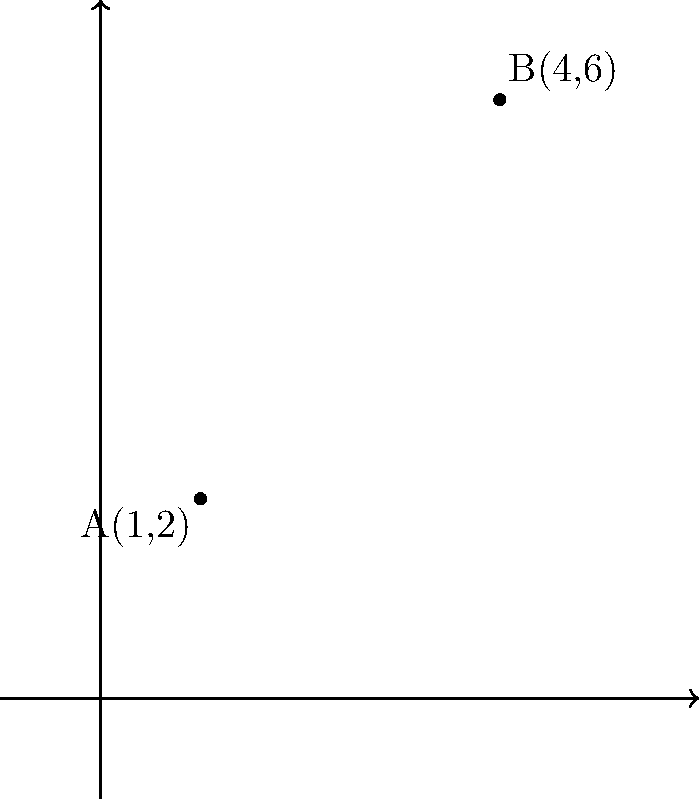In the latest film set, two crucial props are placed at coordinates A(1,2) and B(4,6) on the studio floor grid. As a film critic, you need to determine the distance between these props to assess the cinematographer's framing technique. Using the distance formula, calculate the distance between points A and B. To find the distance between two points on a coordinate plane, we use the distance formula:

$$d = \sqrt{(x_2 - x_1)^2 + (y_2 - y_1)^2}$$

Where $(x_1, y_1)$ are the coordinates of the first point and $(x_2, y_2)$ are the coordinates of the second point.

Given:
Point A: $(1, 2)$
Point B: $(4, 6)$

Let's plug these values into the formula:

$d = \sqrt{(4 - 1)^2 + (6 - 2)^2}$

Now, let's solve step by step:

1) First, calculate the differences:
   $d = \sqrt{(3)^2 + (4)^2}$

2) Square the differences:
   $d = \sqrt{9 + 16}$

3) Add the squared differences:
   $d = \sqrt{25}$

4) Calculate the square root:
   $d = 5$

Therefore, the distance between points A and B is 5 units.
Answer: 5 units 